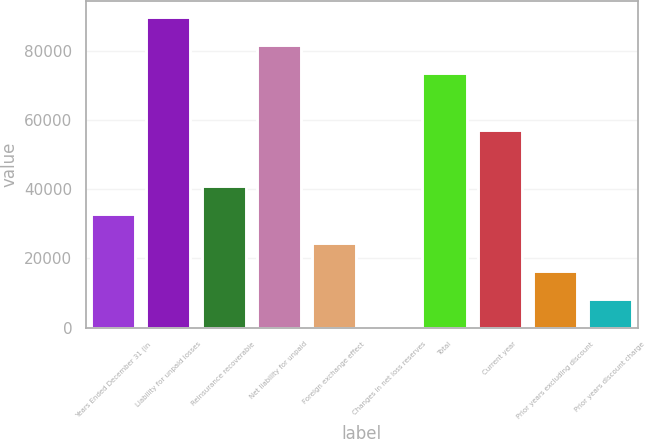<chart> <loc_0><loc_0><loc_500><loc_500><bar_chart><fcel>Years Ended December 31 (in<fcel>Liability for unpaid losses<fcel>Reinsurance recoverable<fcel>Net liability for unpaid<fcel>Foreign exchange effect<fcel>Changes in net loss reserves<fcel>Total<fcel>Current year<fcel>Prior years excluding discount<fcel>Prior years discount charge<nl><fcel>32703.4<fcel>89687.6<fcel>40844<fcel>81547<fcel>24562.8<fcel>141<fcel>73406.4<fcel>57125.2<fcel>16422.2<fcel>8281.6<nl></chart> 